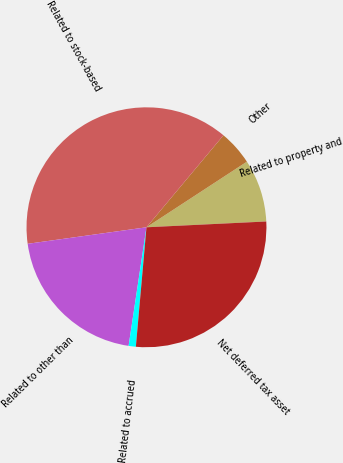Convert chart to OTSL. <chart><loc_0><loc_0><loc_500><loc_500><pie_chart><fcel>Related to property and<fcel>Other<fcel>Related to stock-based<fcel>Related to other than<fcel>Related to accrued<fcel>Net deferred tax asset<nl><fcel>8.44%<fcel>4.7%<fcel>38.29%<fcel>20.42%<fcel>0.97%<fcel>27.18%<nl></chart> 